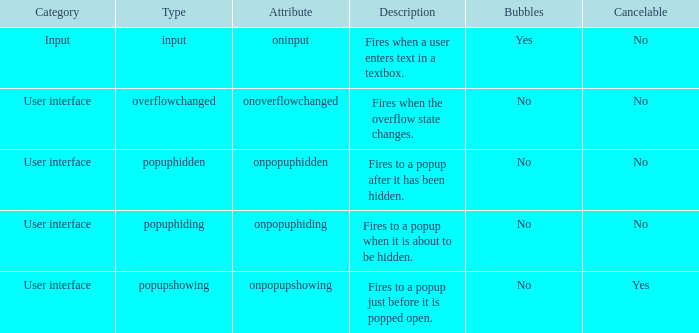What's the characteristic with cancelable being yes? Onpopupshowing. 